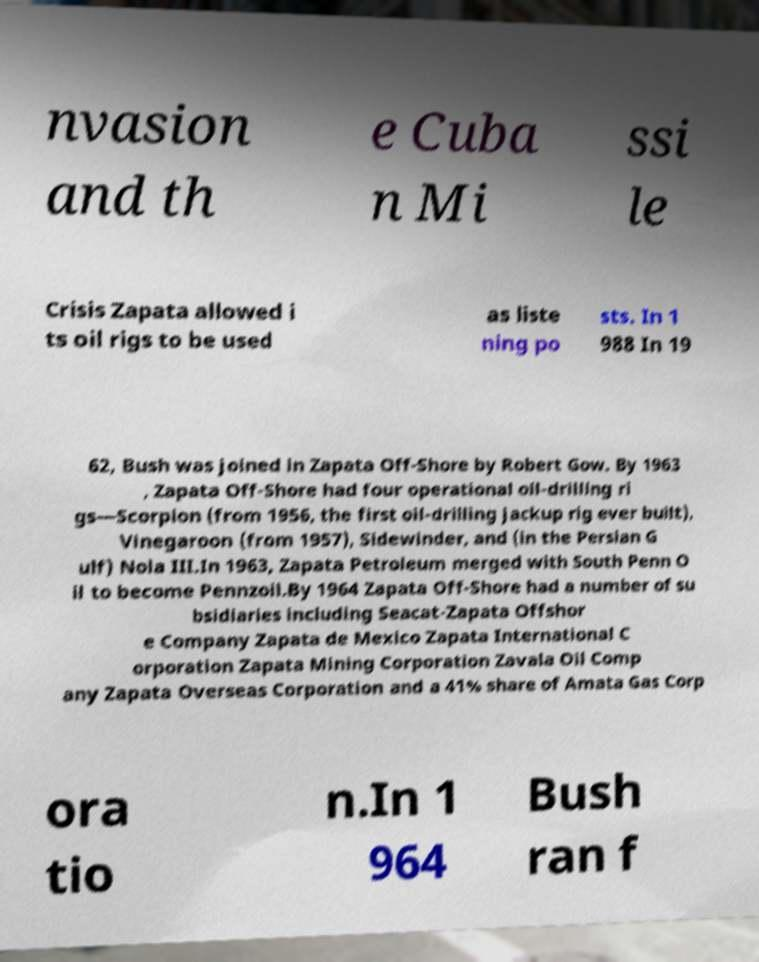There's text embedded in this image that I need extracted. Can you transcribe it verbatim? nvasion and th e Cuba n Mi ssi le Crisis Zapata allowed i ts oil rigs to be used as liste ning po sts. In 1 988 In 19 62, Bush was joined in Zapata Off-Shore by Robert Gow. By 1963 , Zapata Off-Shore had four operational oil-drilling ri gs—Scorpion (from 1956, the first oil-drilling jackup rig ever built), Vinegaroon (from 1957), Sidewinder, and (in the Persian G ulf) Nola III.In 1963, Zapata Petroleum merged with South Penn O il to become Pennzoil.By 1964 Zapata Off-Shore had a number of su bsidiaries including Seacat-Zapata Offshor e Company Zapata de Mexico Zapata International C orporation Zapata Mining Corporation Zavala Oil Comp any Zapata Overseas Corporation and a 41% share of Amata Gas Corp ora tio n.In 1 964 Bush ran f 